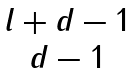<formula> <loc_0><loc_0><loc_500><loc_500>\begin{matrix} l + d - 1 \\ d - 1 \end{matrix}</formula> 